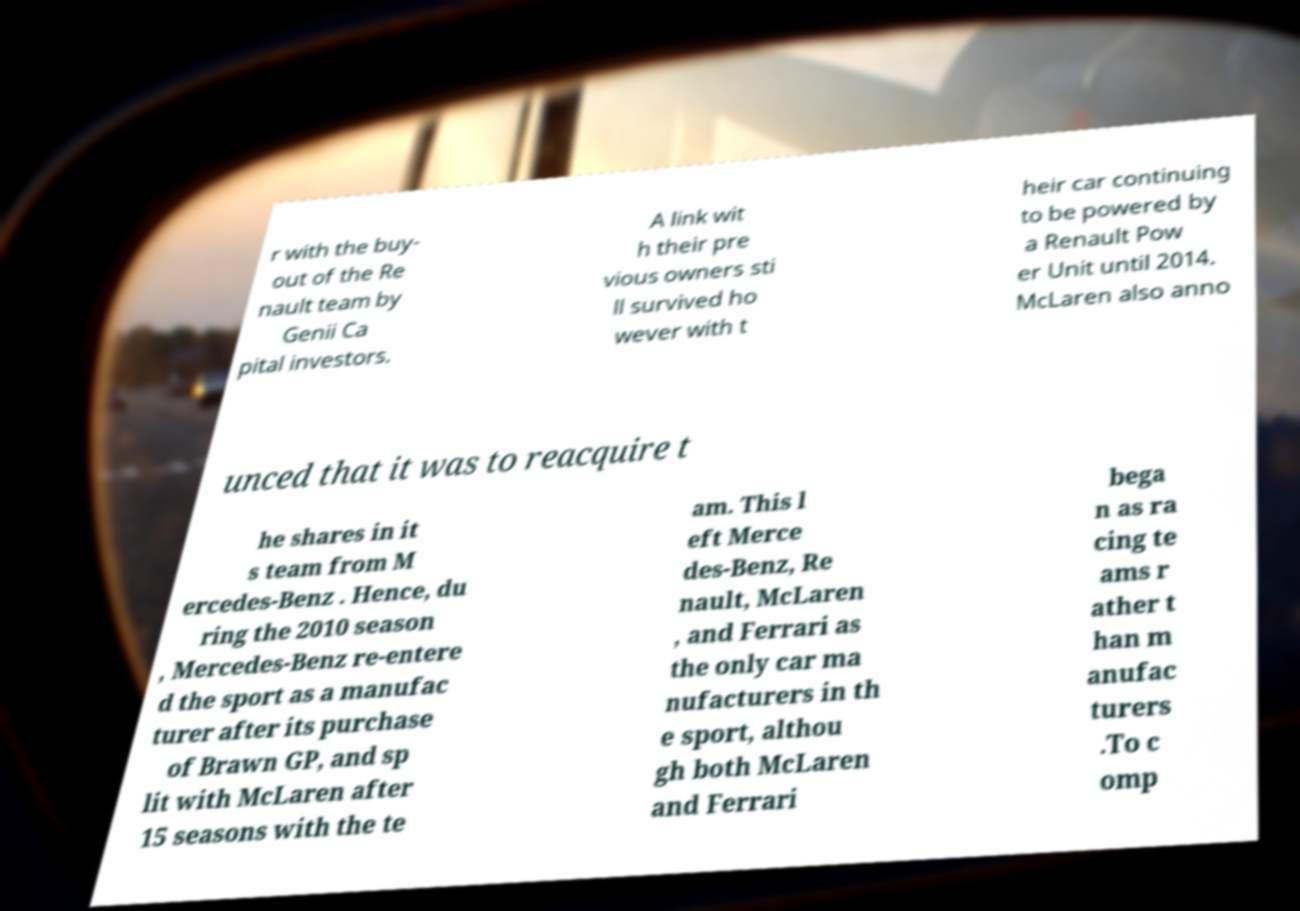Please identify and transcribe the text found in this image. r with the buy- out of the Re nault team by Genii Ca pital investors. A link wit h their pre vious owners sti ll survived ho wever with t heir car continuing to be powered by a Renault Pow er Unit until 2014. McLaren also anno unced that it was to reacquire t he shares in it s team from M ercedes-Benz . Hence, du ring the 2010 season , Mercedes-Benz re-entere d the sport as a manufac turer after its purchase of Brawn GP, and sp lit with McLaren after 15 seasons with the te am. This l eft Merce des-Benz, Re nault, McLaren , and Ferrari as the only car ma nufacturers in th e sport, althou gh both McLaren and Ferrari bega n as ra cing te ams r ather t han m anufac turers .To c omp 